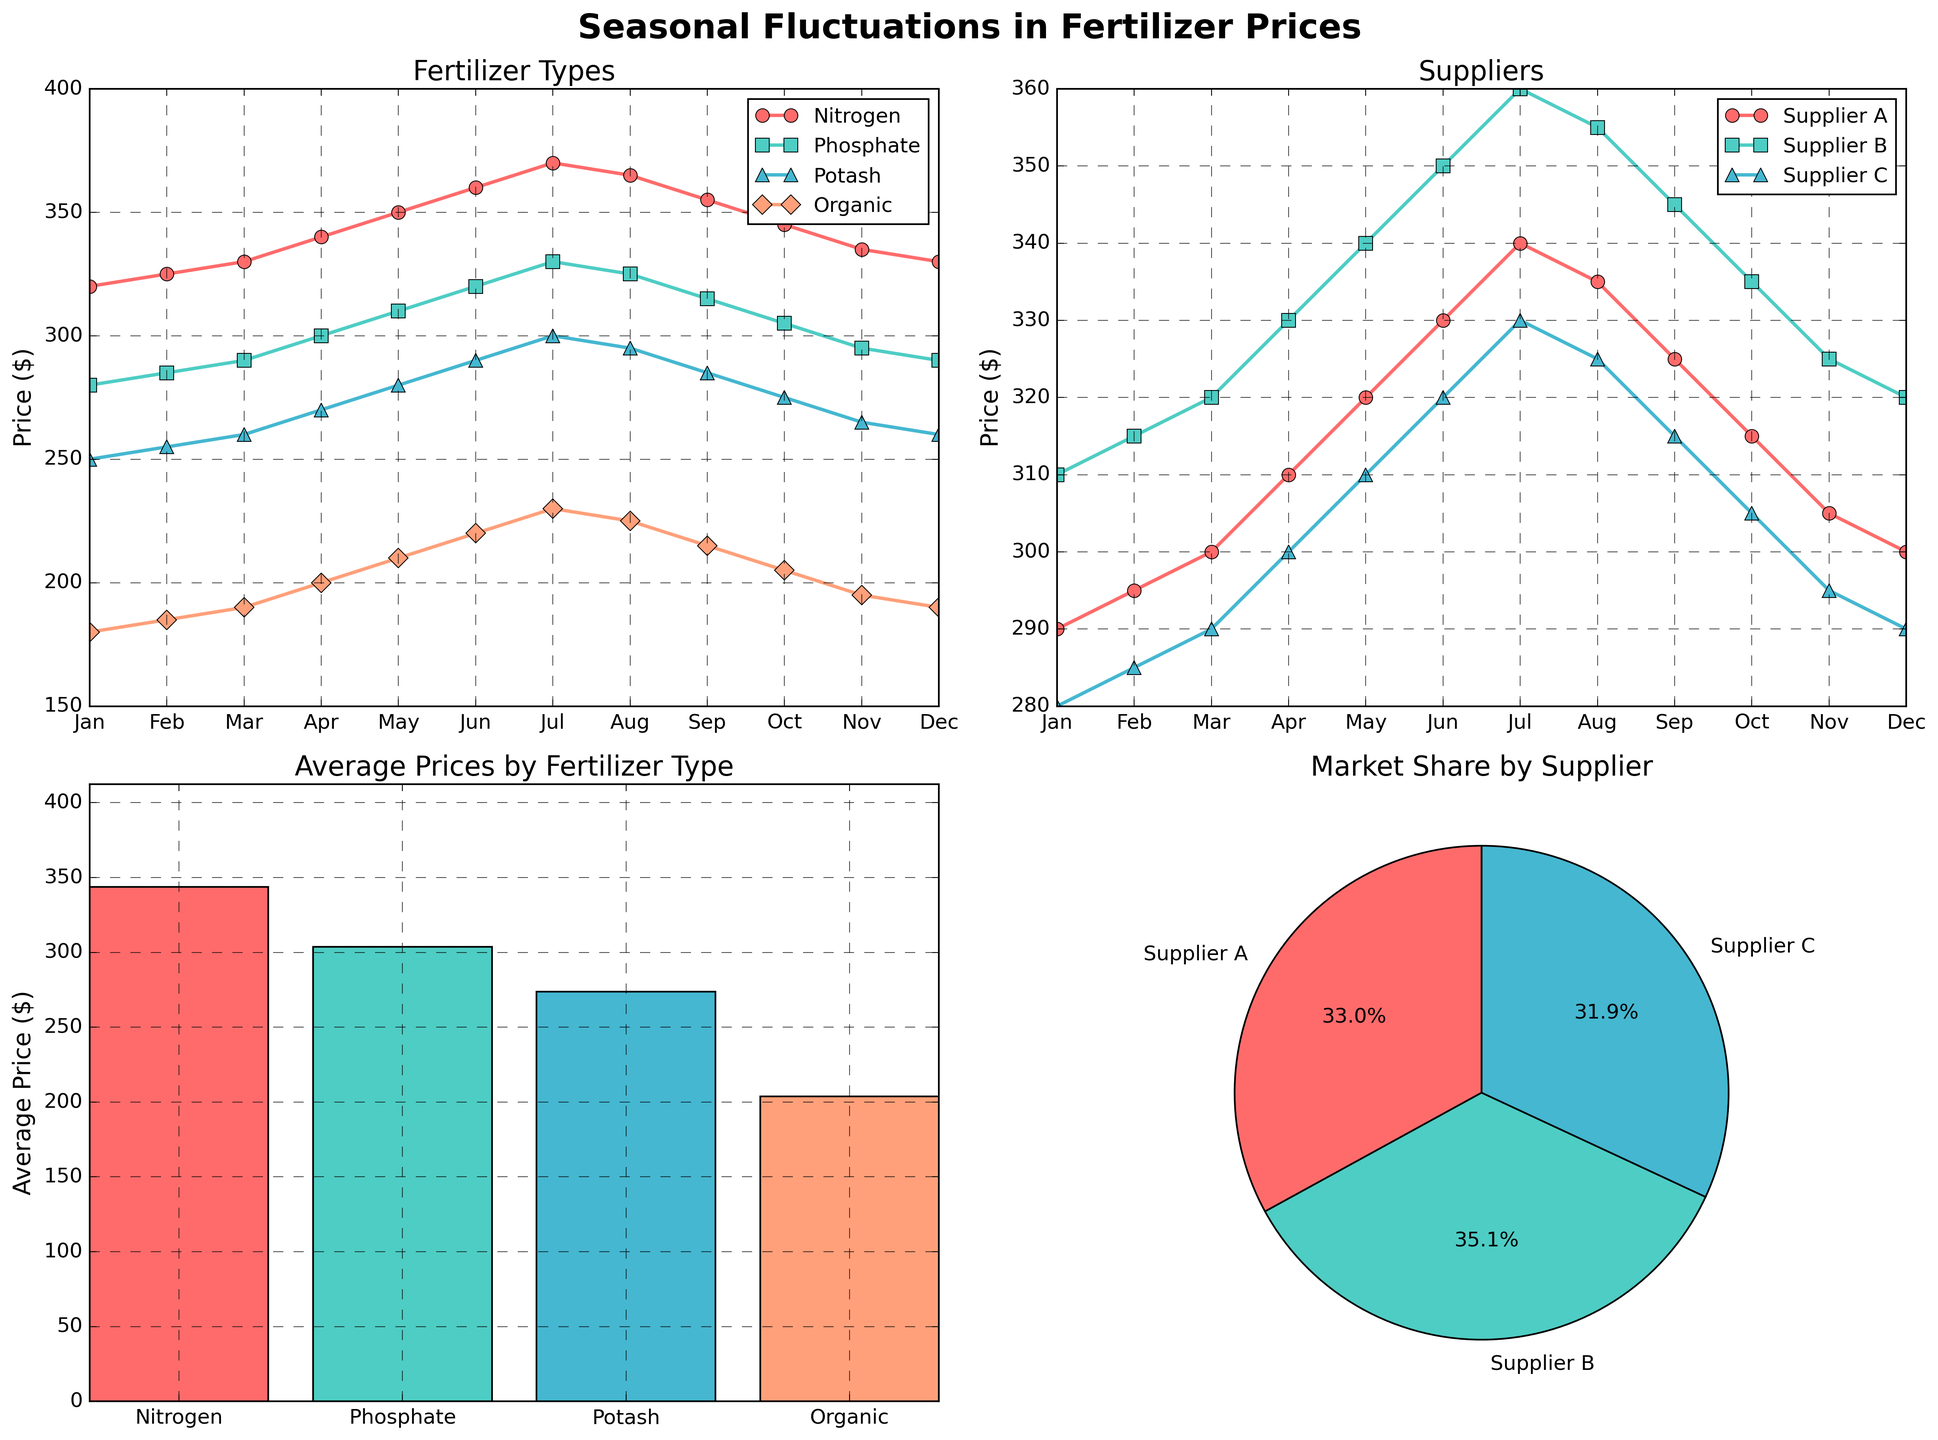What month shows the highest average price for all fertilizer types? To find the month with the highest average price, calculate the average price for each month across all fertilizer types (Nitrogen, Phosphate, Potash, Organic). The month with the highest resulting average is May, with an average price of (350+310+280+210)/4 = 1150/4 = 287.5.
Answer: May Which supplier has the lowest average price over the entire year? Compute the average price for each supplier over all months. Supplier A: (290+295+300+310+320+330+340+335+325+315+305+300)/12 = 3240/12 = 270; Supplier B: (310+315+320+330+340+350+360+355+345+335+325+320)/12 = 4000/12 ≈ 333.33; Supplier C: (280+285+290+300+310+320+330+325+315+305+295+290)/12 = 3625/12 ≈ 302.08. Supplier A has the lowest average price.
Answer: Supplier A How do the prices for organic fertilizer fluctuate from January to December? Refer to the subplot showing fertilizer types. The price for Organic fertilizer starts at $180 in January, increases steadily to a peak of $230 in July, then decreases back to $190 by December.
Answer: It increases to $230 by July then decreases to $190 Which supplier shows the greatest price fluctuation over the year? Compare the range (max price - min price) for each supplier. Supplier A ranges from $290 to $340, a fluctuation of $50. Supplier B ranges from $310 to $360, a fluctuation of $50. Supplier C ranges from $280 to $330, a fluctuation of $50. All suppliers have the same fluctuation range of $50.
Answer: All equal Between Nitrogen and Phosphate, which has a greater price increase from January to July? Refer to the subplot showing fertilizer types. Nitrogen increases from $320 to $370, a change of $50. Phosphate increases from $280 to $330, also a change of $50. Both fertilizers have the same price increase from January to July.
Answer: Both equal Is the average price of Phosphate ever higher than the average price of Potash? Check the average prices in the corresponding subplot. The average price of Phosphate is $301.67, and the average price of Potash is $277.5. Phosphate’s average price is consistently higher than Potash.
Answer: Yes Which month shows the lowest price for Nitrogen fertilizer? Refer to the subplot for fertilizer types. The lowest price for Nitrogen appears in January and December at $320.
Answer: January and December What is the market share percentage of Supplier B according to the pie chart? Refer to the market share subplot. Supplier B holds approximately 36.7% of the market share.
Answer: 36.7% How do the prices of Supplier A and Supplier B compare in November? Refer to the subplot for suppliers. In November, Supplier A’s price is $305, while Supplier B’s price is $325. Therefore, Supplier B’s price is higher.
Answer: Supplier B is higher 